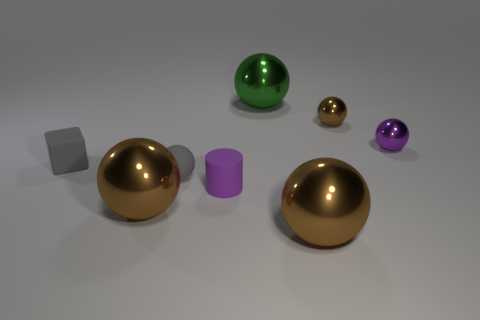Subtract all purple balls. How many balls are left? 5 Subtract 3 balls. How many balls are left? 3 Subtract all brown spheres. How many spheres are left? 3 Add 1 tiny brown shiny things. How many objects exist? 9 Subtract all blocks. How many objects are left? 7 Add 2 matte balls. How many matte balls are left? 3 Add 3 tiny brown metal objects. How many tiny brown metal objects exist? 4 Subtract 0 green blocks. How many objects are left? 8 Subtract all yellow blocks. Subtract all blue balls. How many blocks are left? 1 Subtract all brown cubes. How many brown spheres are left? 3 